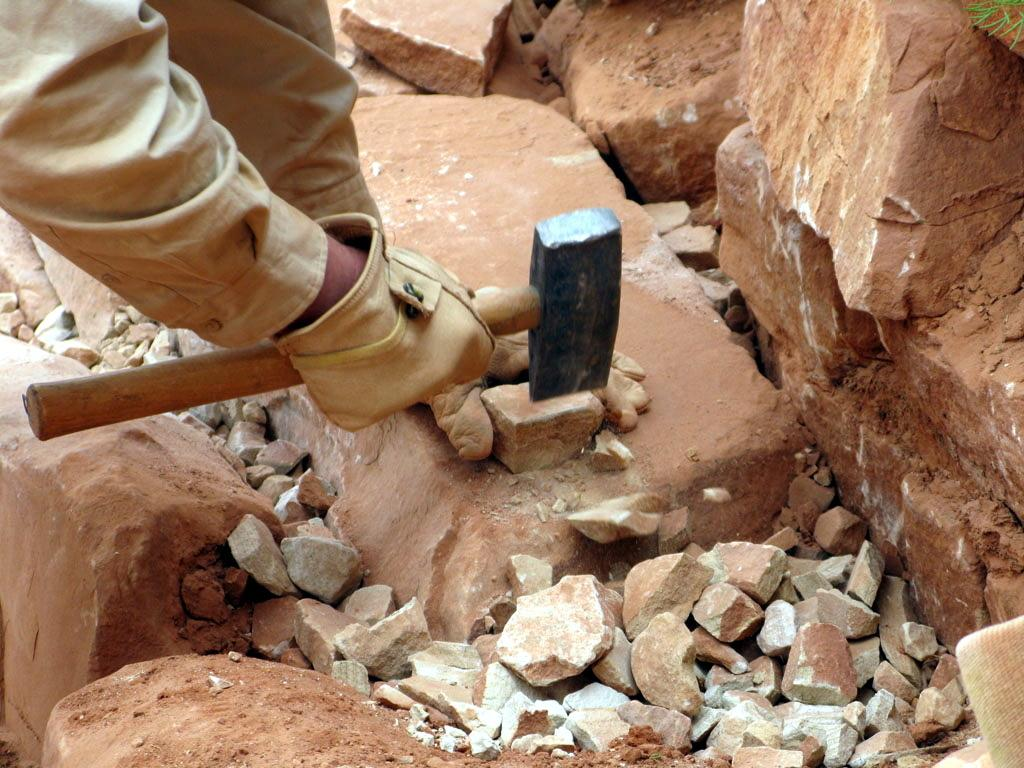What is the main subject of the image? There is a person in the image. What is the person holding in the image? The person is holding a hammer. What is the hammer resting on in the image? The hammer is on a stone. What can be seen in the background of the image? There are other stones in the background of the image. What color are the stones in the background? The stones in the background are brown in color. What type of grass is growing around the person in the image? There is no grass visible in the image; it features a person holding a hammer on a stone with other brown stones in the background. 